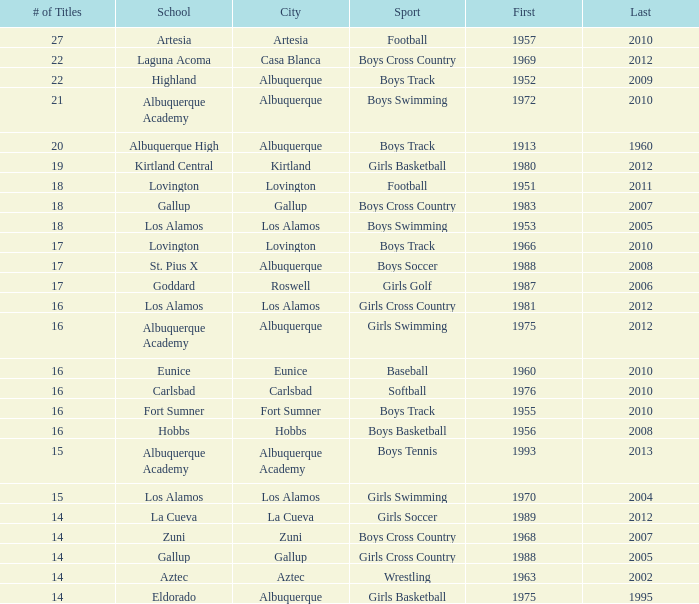What is the top position for the boys swimming team in albuquerque? 3.0. 